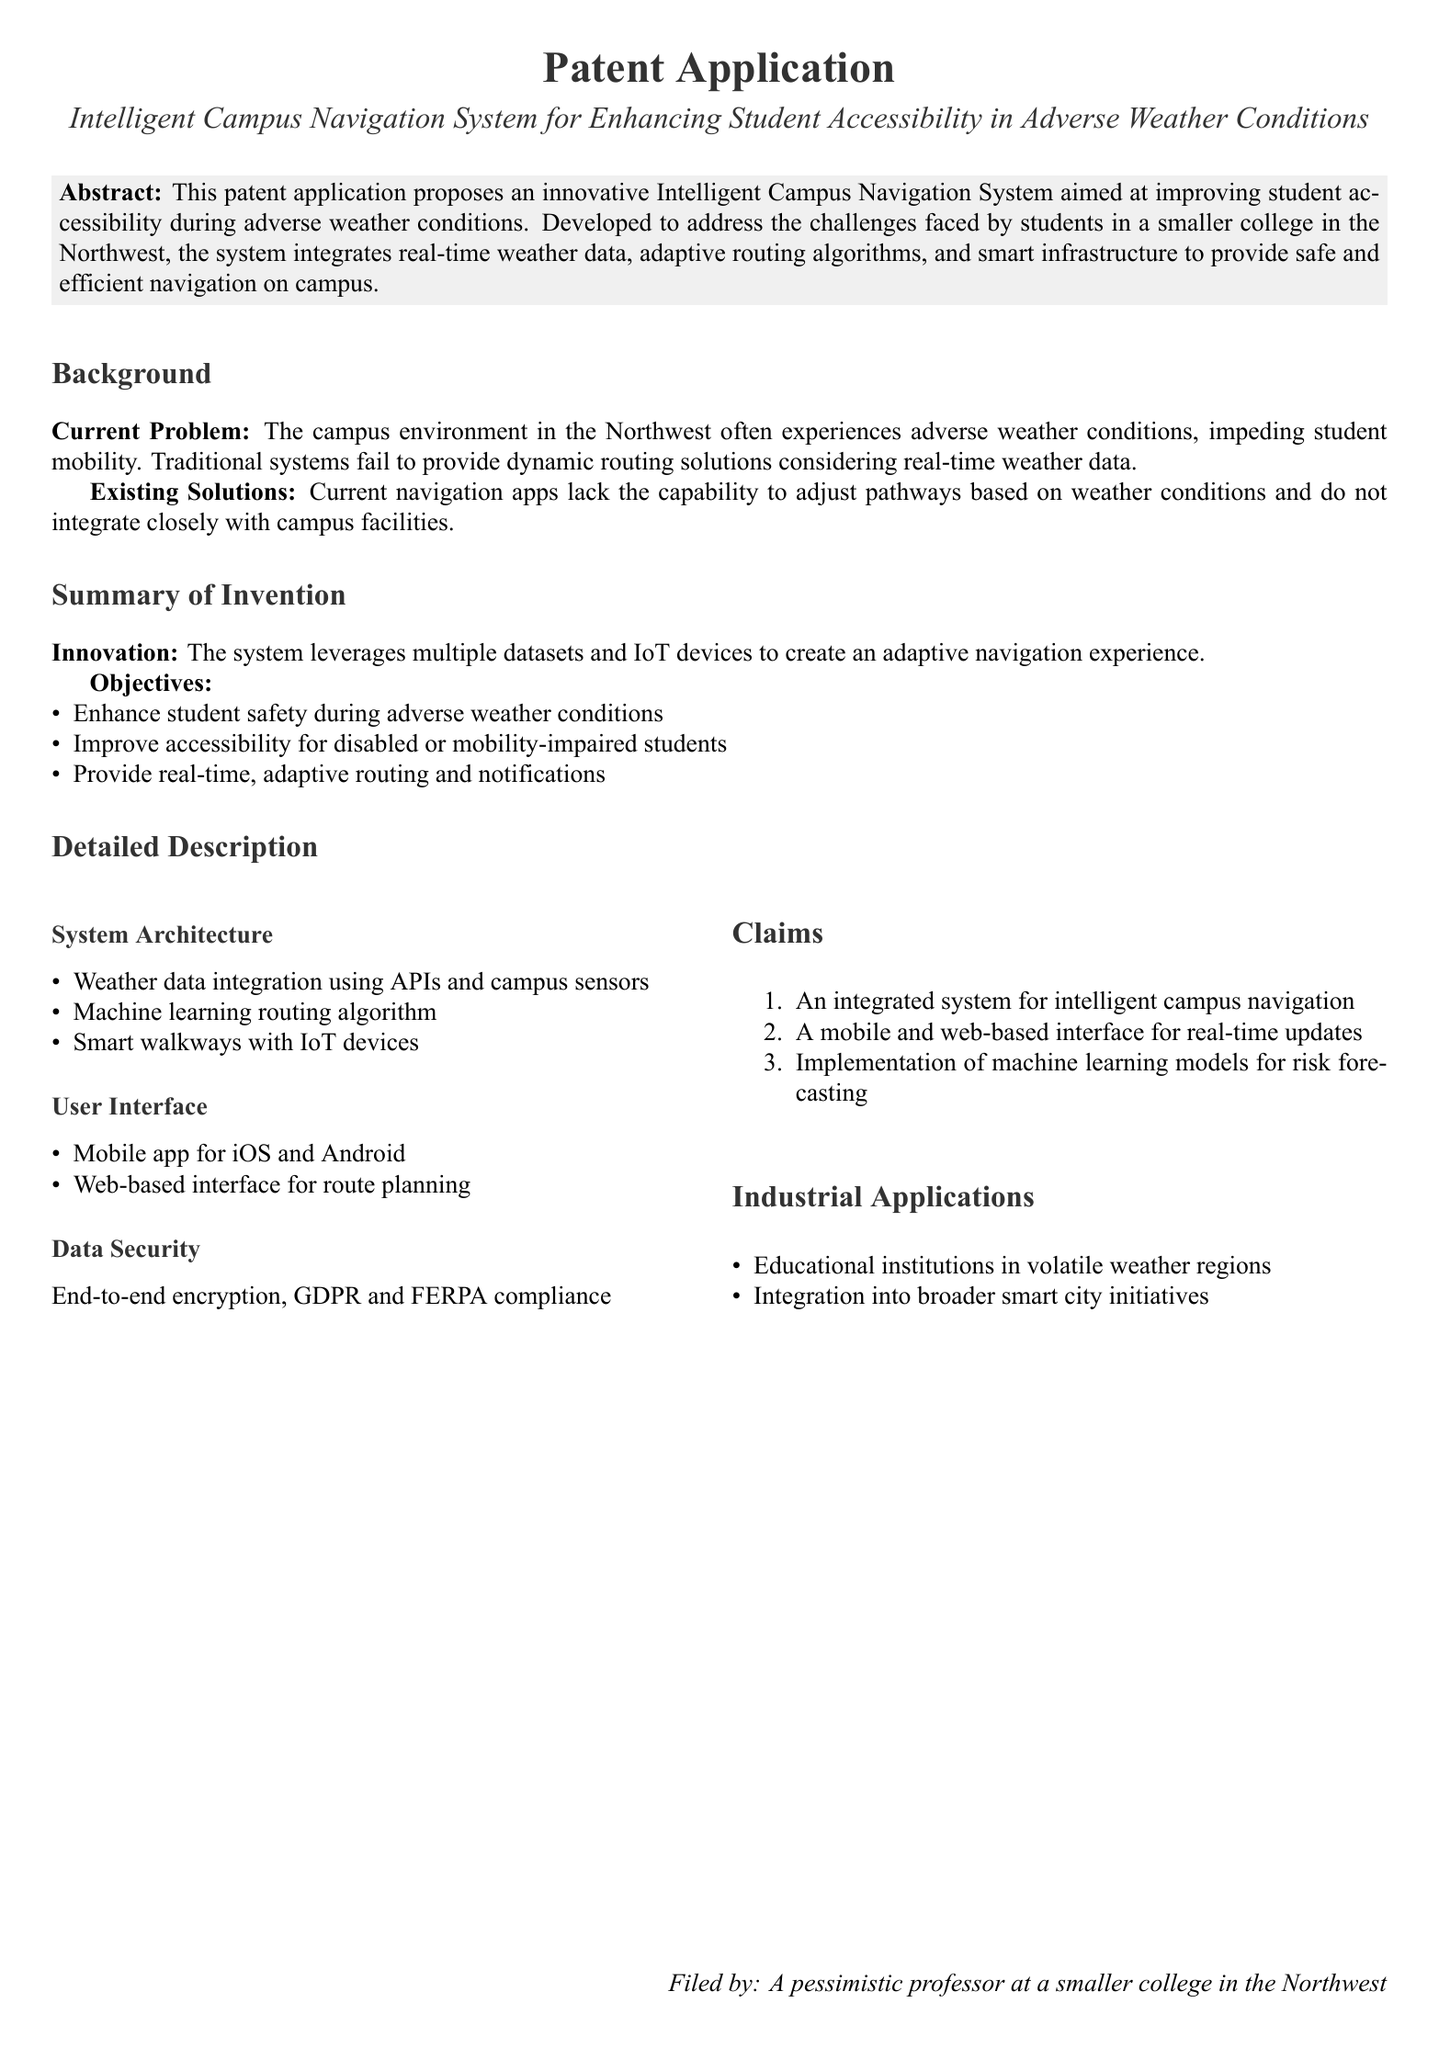what is the title of the patent application? The title of the patent application is stated prominently in the document.
Answer: Intelligent Campus Navigation System for Enhancing Student Accessibility in Adverse Weather Conditions what are the objectives listed for the system? The objectives are explicitly outlined in the document under the "Objectives" section.
Answer: Enhance student safety during adverse weather conditions, Improve accessibility for disabled or mobility-impaired students, Provide real-time, adaptive routing and notifications how many claims are made in the patent application? The number of claims is specified in the "Claims" section of the document.
Answer: Three what is the focus of the "Summary of Invention" section? This section details the innovations and goals of the invention as listed in the document.
Answer: The system leverages multiple datasets and IoT devices to create an adaptive navigation experience which compliance standards does the system adhere to? The data security measures mentioned in the document highlight compliance standards.
Answer: GDPR and FERPA compliance what is the main problem the system aims to solve? The main problem is addressed in the "Current Problem" subsection of the "Background" section.
Answer: Adverse weather conditions impeding student mobility what type of architecture does the system use? The system architecture is summarized under the "System Architecture" subsection.
Answer: Weather data integration using APIs and campus sensors who filed the patent application? The identity of the filer is mentioned at the end of the document.
Answer: A pessimistic professor at a smaller college in the Northwest 